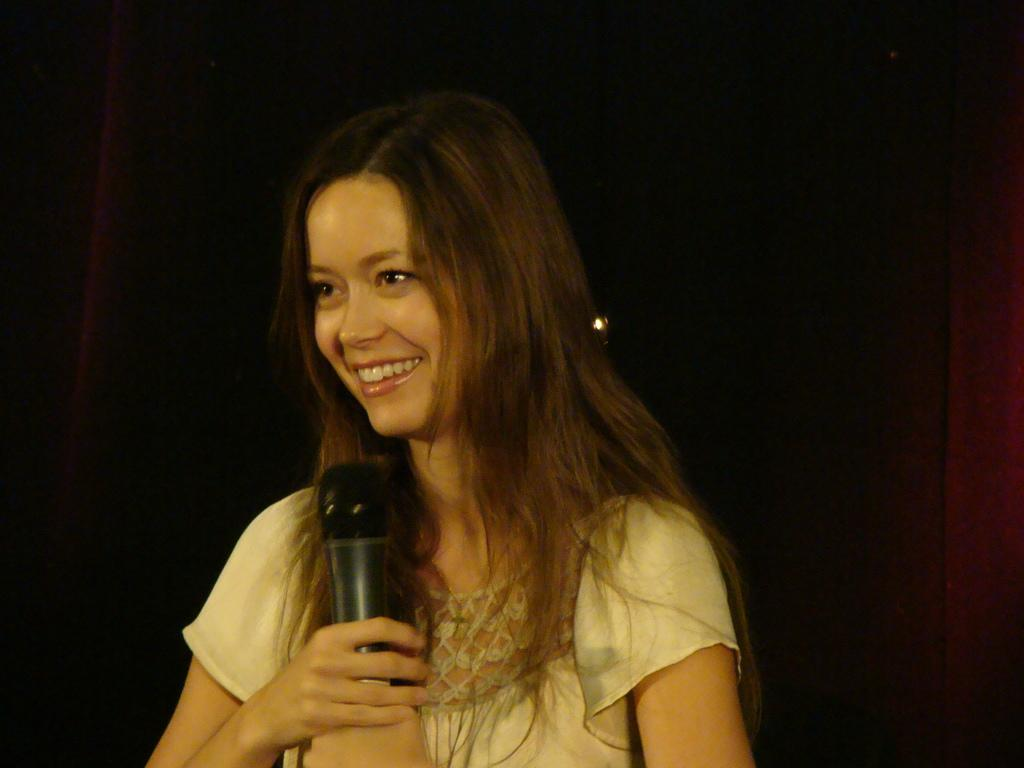Who is the main subject in the image? There is a woman in the image. Where is the woman positioned in the image? The woman is standing in the center. What is the woman holding in her hand? The woman is holding a microphone in her hand. What expression does the woman have on her face? The woman has a pretty smile on her face. What type of pan is the woman using to scare away the crows in the image? There is no pan or crows present in the image. The woman is holding a microphone and has a pretty smile on her face. 